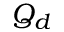Convert formula to latex. <formula><loc_0><loc_0><loc_500><loc_500>Q _ { d }</formula> 